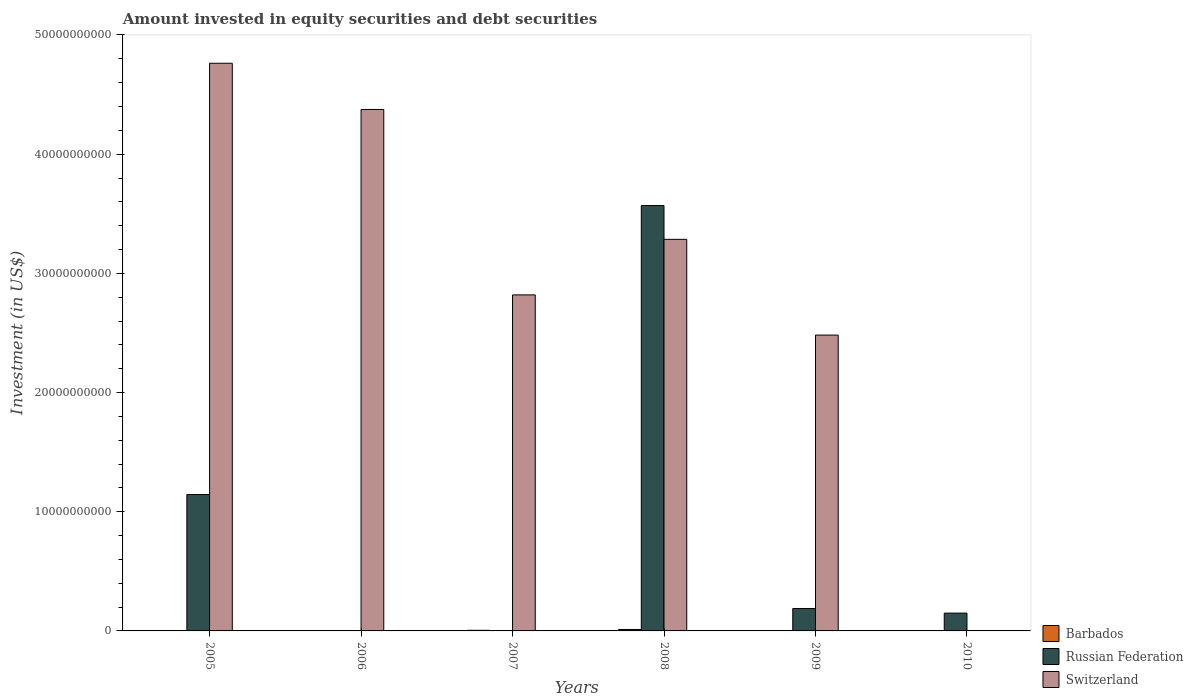How many different coloured bars are there?
Make the answer very short. 3. Are the number of bars per tick equal to the number of legend labels?
Offer a terse response. No. How many bars are there on the 5th tick from the left?
Keep it short and to the point. 2. How many bars are there on the 5th tick from the right?
Give a very brief answer. 1. What is the label of the 4th group of bars from the left?
Ensure brevity in your answer.  2008. In how many cases, is the number of bars for a given year not equal to the number of legend labels?
Offer a very short reply. 5. What is the amount invested in equity securities and debt securities in Switzerland in 2010?
Your answer should be very brief. 0. Across all years, what is the maximum amount invested in equity securities and debt securities in Barbados?
Ensure brevity in your answer.  1.23e+08. What is the total amount invested in equity securities and debt securities in Barbados in the graph?
Your response must be concise. 1.74e+08. What is the difference between the amount invested in equity securities and debt securities in Russian Federation in 2005 and that in 2010?
Your answer should be very brief. 9.95e+09. What is the difference between the amount invested in equity securities and debt securities in Russian Federation in 2009 and the amount invested in equity securities and debt securities in Barbados in 2006?
Provide a short and direct response. 1.88e+09. What is the average amount invested in equity securities and debt securities in Russian Federation per year?
Provide a succinct answer. 8.42e+09. In the year 2008, what is the difference between the amount invested in equity securities and debt securities in Russian Federation and amount invested in equity securities and debt securities in Switzerland?
Offer a very short reply. 2.84e+09. What is the ratio of the amount invested in equity securities and debt securities in Switzerland in 2007 to that in 2008?
Your response must be concise. 0.86. What is the difference between the highest and the second highest amount invested in equity securities and debt securities in Switzerland?
Provide a short and direct response. 3.88e+09. What is the difference between the highest and the lowest amount invested in equity securities and debt securities in Barbados?
Ensure brevity in your answer.  1.23e+08. In how many years, is the amount invested in equity securities and debt securities in Switzerland greater than the average amount invested in equity securities and debt securities in Switzerland taken over all years?
Your answer should be compact. 3. Is it the case that in every year, the sum of the amount invested in equity securities and debt securities in Switzerland and amount invested in equity securities and debt securities in Russian Federation is greater than the amount invested in equity securities and debt securities in Barbados?
Provide a succinct answer. Yes. Are all the bars in the graph horizontal?
Make the answer very short. No. Does the graph contain any zero values?
Your response must be concise. Yes. Where does the legend appear in the graph?
Your response must be concise. Bottom right. What is the title of the graph?
Ensure brevity in your answer.  Amount invested in equity securities and debt securities. Does "Indonesia" appear as one of the legend labels in the graph?
Offer a very short reply. No. What is the label or title of the X-axis?
Offer a terse response. Years. What is the label or title of the Y-axis?
Give a very brief answer. Investment (in US$). What is the Investment (in US$) in Russian Federation in 2005?
Keep it short and to the point. 1.14e+1. What is the Investment (in US$) in Switzerland in 2005?
Offer a very short reply. 4.76e+1. What is the Investment (in US$) in Russian Federation in 2006?
Your response must be concise. 0. What is the Investment (in US$) of Switzerland in 2006?
Give a very brief answer. 4.37e+1. What is the Investment (in US$) of Barbados in 2007?
Provide a succinct answer. 5.16e+07. What is the Investment (in US$) of Switzerland in 2007?
Offer a terse response. 2.82e+1. What is the Investment (in US$) in Barbados in 2008?
Provide a succinct answer. 1.23e+08. What is the Investment (in US$) in Russian Federation in 2008?
Provide a short and direct response. 3.57e+1. What is the Investment (in US$) of Switzerland in 2008?
Your response must be concise. 3.29e+1. What is the Investment (in US$) of Russian Federation in 2009?
Provide a short and direct response. 1.88e+09. What is the Investment (in US$) in Switzerland in 2009?
Provide a succinct answer. 2.48e+1. What is the Investment (in US$) in Barbados in 2010?
Offer a very short reply. 0. What is the Investment (in US$) of Russian Federation in 2010?
Provide a succinct answer. 1.50e+09. Across all years, what is the maximum Investment (in US$) in Barbados?
Keep it short and to the point. 1.23e+08. Across all years, what is the maximum Investment (in US$) of Russian Federation?
Your answer should be very brief. 3.57e+1. Across all years, what is the maximum Investment (in US$) in Switzerland?
Your response must be concise. 4.76e+1. Across all years, what is the minimum Investment (in US$) of Barbados?
Ensure brevity in your answer.  0. Across all years, what is the minimum Investment (in US$) of Russian Federation?
Keep it short and to the point. 0. What is the total Investment (in US$) of Barbados in the graph?
Make the answer very short. 1.74e+08. What is the total Investment (in US$) in Russian Federation in the graph?
Keep it short and to the point. 5.05e+1. What is the total Investment (in US$) of Switzerland in the graph?
Offer a terse response. 1.77e+11. What is the difference between the Investment (in US$) in Switzerland in 2005 and that in 2006?
Offer a terse response. 3.88e+09. What is the difference between the Investment (in US$) in Switzerland in 2005 and that in 2007?
Your answer should be very brief. 1.94e+1. What is the difference between the Investment (in US$) of Russian Federation in 2005 and that in 2008?
Provide a succinct answer. -2.42e+1. What is the difference between the Investment (in US$) of Switzerland in 2005 and that in 2008?
Provide a short and direct response. 1.48e+1. What is the difference between the Investment (in US$) of Russian Federation in 2005 and that in 2009?
Your answer should be compact. 9.56e+09. What is the difference between the Investment (in US$) of Switzerland in 2005 and that in 2009?
Offer a terse response. 2.28e+1. What is the difference between the Investment (in US$) of Russian Federation in 2005 and that in 2010?
Make the answer very short. 9.95e+09. What is the difference between the Investment (in US$) in Switzerland in 2006 and that in 2007?
Make the answer very short. 1.56e+1. What is the difference between the Investment (in US$) in Switzerland in 2006 and that in 2008?
Your answer should be very brief. 1.09e+1. What is the difference between the Investment (in US$) of Switzerland in 2006 and that in 2009?
Your answer should be very brief. 1.89e+1. What is the difference between the Investment (in US$) in Barbados in 2007 and that in 2008?
Keep it short and to the point. -7.11e+07. What is the difference between the Investment (in US$) of Switzerland in 2007 and that in 2008?
Your response must be concise. -4.66e+09. What is the difference between the Investment (in US$) of Switzerland in 2007 and that in 2009?
Keep it short and to the point. 3.37e+09. What is the difference between the Investment (in US$) in Russian Federation in 2008 and that in 2009?
Ensure brevity in your answer.  3.38e+1. What is the difference between the Investment (in US$) of Switzerland in 2008 and that in 2009?
Make the answer very short. 8.03e+09. What is the difference between the Investment (in US$) in Russian Federation in 2008 and that in 2010?
Provide a succinct answer. 3.42e+1. What is the difference between the Investment (in US$) in Russian Federation in 2009 and that in 2010?
Offer a very short reply. 3.87e+08. What is the difference between the Investment (in US$) of Russian Federation in 2005 and the Investment (in US$) of Switzerland in 2006?
Your response must be concise. -3.23e+1. What is the difference between the Investment (in US$) of Russian Federation in 2005 and the Investment (in US$) of Switzerland in 2007?
Your response must be concise. -1.68e+1. What is the difference between the Investment (in US$) in Russian Federation in 2005 and the Investment (in US$) in Switzerland in 2008?
Provide a short and direct response. -2.14e+1. What is the difference between the Investment (in US$) of Russian Federation in 2005 and the Investment (in US$) of Switzerland in 2009?
Your answer should be very brief. -1.34e+1. What is the difference between the Investment (in US$) of Barbados in 2007 and the Investment (in US$) of Russian Federation in 2008?
Your answer should be very brief. -3.56e+1. What is the difference between the Investment (in US$) of Barbados in 2007 and the Investment (in US$) of Switzerland in 2008?
Offer a terse response. -3.28e+1. What is the difference between the Investment (in US$) of Barbados in 2007 and the Investment (in US$) of Russian Federation in 2009?
Provide a succinct answer. -1.83e+09. What is the difference between the Investment (in US$) of Barbados in 2007 and the Investment (in US$) of Switzerland in 2009?
Your answer should be very brief. -2.48e+1. What is the difference between the Investment (in US$) in Barbados in 2007 and the Investment (in US$) in Russian Federation in 2010?
Keep it short and to the point. -1.44e+09. What is the difference between the Investment (in US$) in Barbados in 2008 and the Investment (in US$) in Russian Federation in 2009?
Offer a terse response. -1.76e+09. What is the difference between the Investment (in US$) in Barbados in 2008 and the Investment (in US$) in Switzerland in 2009?
Offer a very short reply. -2.47e+1. What is the difference between the Investment (in US$) of Russian Federation in 2008 and the Investment (in US$) of Switzerland in 2009?
Your response must be concise. 1.09e+1. What is the difference between the Investment (in US$) of Barbados in 2008 and the Investment (in US$) of Russian Federation in 2010?
Provide a succinct answer. -1.37e+09. What is the average Investment (in US$) in Barbados per year?
Offer a terse response. 2.90e+07. What is the average Investment (in US$) of Russian Federation per year?
Keep it short and to the point. 8.42e+09. What is the average Investment (in US$) in Switzerland per year?
Your answer should be very brief. 2.95e+1. In the year 2005, what is the difference between the Investment (in US$) in Russian Federation and Investment (in US$) in Switzerland?
Your answer should be very brief. -3.62e+1. In the year 2007, what is the difference between the Investment (in US$) of Barbados and Investment (in US$) of Switzerland?
Your answer should be very brief. -2.81e+1. In the year 2008, what is the difference between the Investment (in US$) of Barbados and Investment (in US$) of Russian Federation?
Offer a terse response. -3.56e+1. In the year 2008, what is the difference between the Investment (in US$) in Barbados and Investment (in US$) in Switzerland?
Your answer should be compact. -3.27e+1. In the year 2008, what is the difference between the Investment (in US$) of Russian Federation and Investment (in US$) of Switzerland?
Ensure brevity in your answer.  2.84e+09. In the year 2009, what is the difference between the Investment (in US$) in Russian Federation and Investment (in US$) in Switzerland?
Your answer should be compact. -2.29e+1. What is the ratio of the Investment (in US$) in Switzerland in 2005 to that in 2006?
Ensure brevity in your answer.  1.09. What is the ratio of the Investment (in US$) in Switzerland in 2005 to that in 2007?
Provide a short and direct response. 1.69. What is the ratio of the Investment (in US$) of Russian Federation in 2005 to that in 2008?
Your answer should be very brief. 0.32. What is the ratio of the Investment (in US$) of Switzerland in 2005 to that in 2008?
Keep it short and to the point. 1.45. What is the ratio of the Investment (in US$) in Russian Federation in 2005 to that in 2009?
Your answer should be very brief. 6.08. What is the ratio of the Investment (in US$) of Switzerland in 2005 to that in 2009?
Ensure brevity in your answer.  1.92. What is the ratio of the Investment (in US$) in Russian Federation in 2005 to that in 2010?
Give a very brief answer. 7.65. What is the ratio of the Investment (in US$) in Switzerland in 2006 to that in 2007?
Make the answer very short. 1.55. What is the ratio of the Investment (in US$) in Switzerland in 2006 to that in 2008?
Keep it short and to the point. 1.33. What is the ratio of the Investment (in US$) of Switzerland in 2006 to that in 2009?
Give a very brief answer. 1.76. What is the ratio of the Investment (in US$) of Barbados in 2007 to that in 2008?
Ensure brevity in your answer.  0.42. What is the ratio of the Investment (in US$) in Switzerland in 2007 to that in 2008?
Offer a very short reply. 0.86. What is the ratio of the Investment (in US$) in Switzerland in 2007 to that in 2009?
Provide a short and direct response. 1.14. What is the ratio of the Investment (in US$) in Russian Federation in 2008 to that in 2009?
Offer a terse response. 18.96. What is the ratio of the Investment (in US$) of Switzerland in 2008 to that in 2009?
Your response must be concise. 1.32. What is the ratio of the Investment (in US$) in Russian Federation in 2008 to that in 2010?
Make the answer very short. 23.87. What is the ratio of the Investment (in US$) of Russian Federation in 2009 to that in 2010?
Keep it short and to the point. 1.26. What is the difference between the highest and the second highest Investment (in US$) in Russian Federation?
Keep it short and to the point. 2.42e+1. What is the difference between the highest and the second highest Investment (in US$) of Switzerland?
Your answer should be compact. 3.88e+09. What is the difference between the highest and the lowest Investment (in US$) in Barbados?
Provide a succinct answer. 1.23e+08. What is the difference between the highest and the lowest Investment (in US$) in Russian Federation?
Provide a succinct answer. 3.57e+1. What is the difference between the highest and the lowest Investment (in US$) in Switzerland?
Keep it short and to the point. 4.76e+1. 